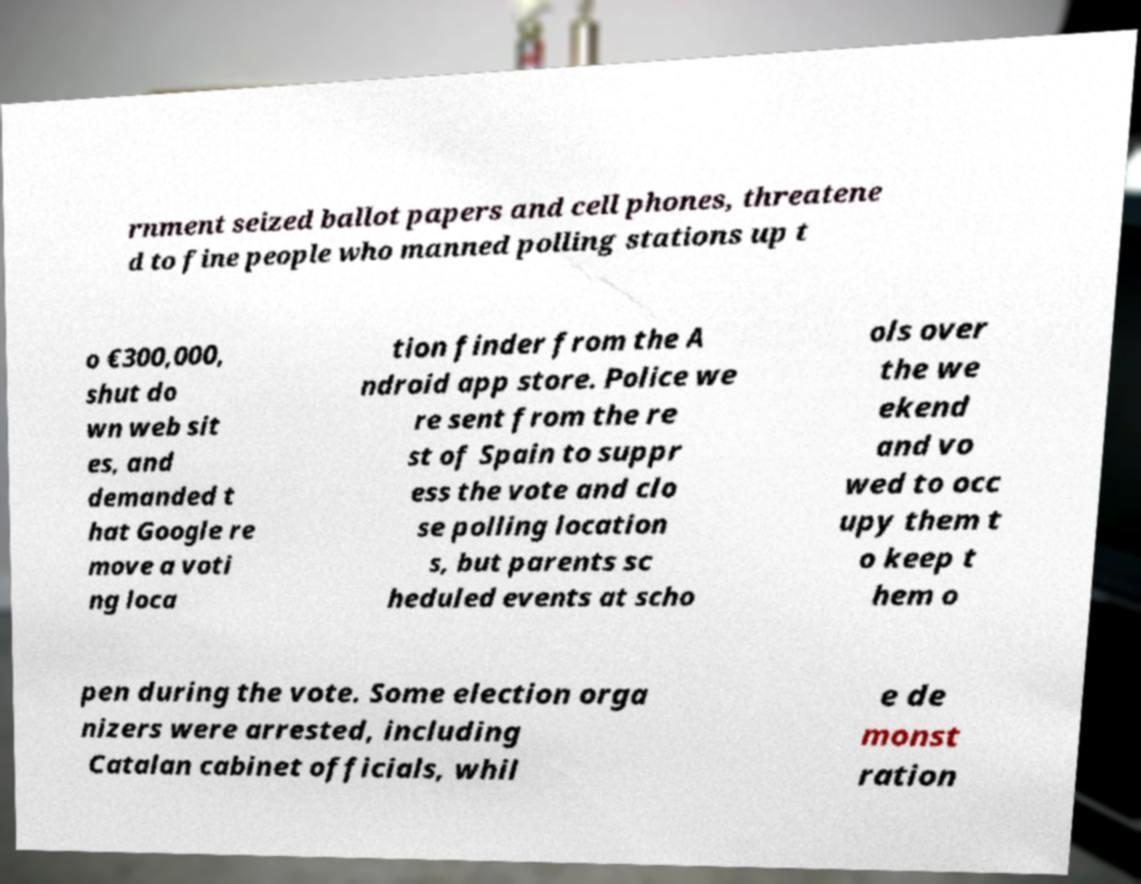Could you extract and type out the text from this image? rnment seized ballot papers and cell phones, threatene d to fine people who manned polling stations up t o €300,000, shut do wn web sit es, and demanded t hat Google re move a voti ng loca tion finder from the A ndroid app store. Police we re sent from the re st of Spain to suppr ess the vote and clo se polling location s, but parents sc heduled events at scho ols over the we ekend and vo wed to occ upy them t o keep t hem o pen during the vote. Some election orga nizers were arrested, including Catalan cabinet officials, whil e de monst ration 